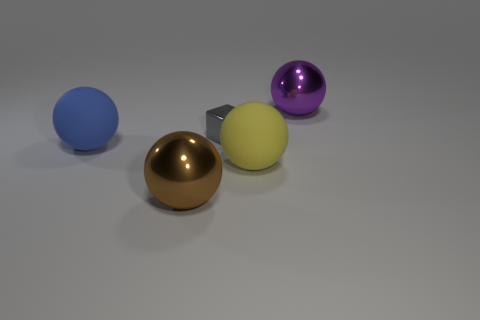Add 2 blue rubber things. How many objects exist? 7 Subtract all blocks. How many objects are left? 4 Add 2 yellow balls. How many yellow balls are left? 3 Add 1 big brown spheres. How many big brown spheres exist? 2 Subtract 0 yellow cubes. How many objects are left? 5 Subtract all gray shiny things. Subtract all big blue things. How many objects are left? 3 